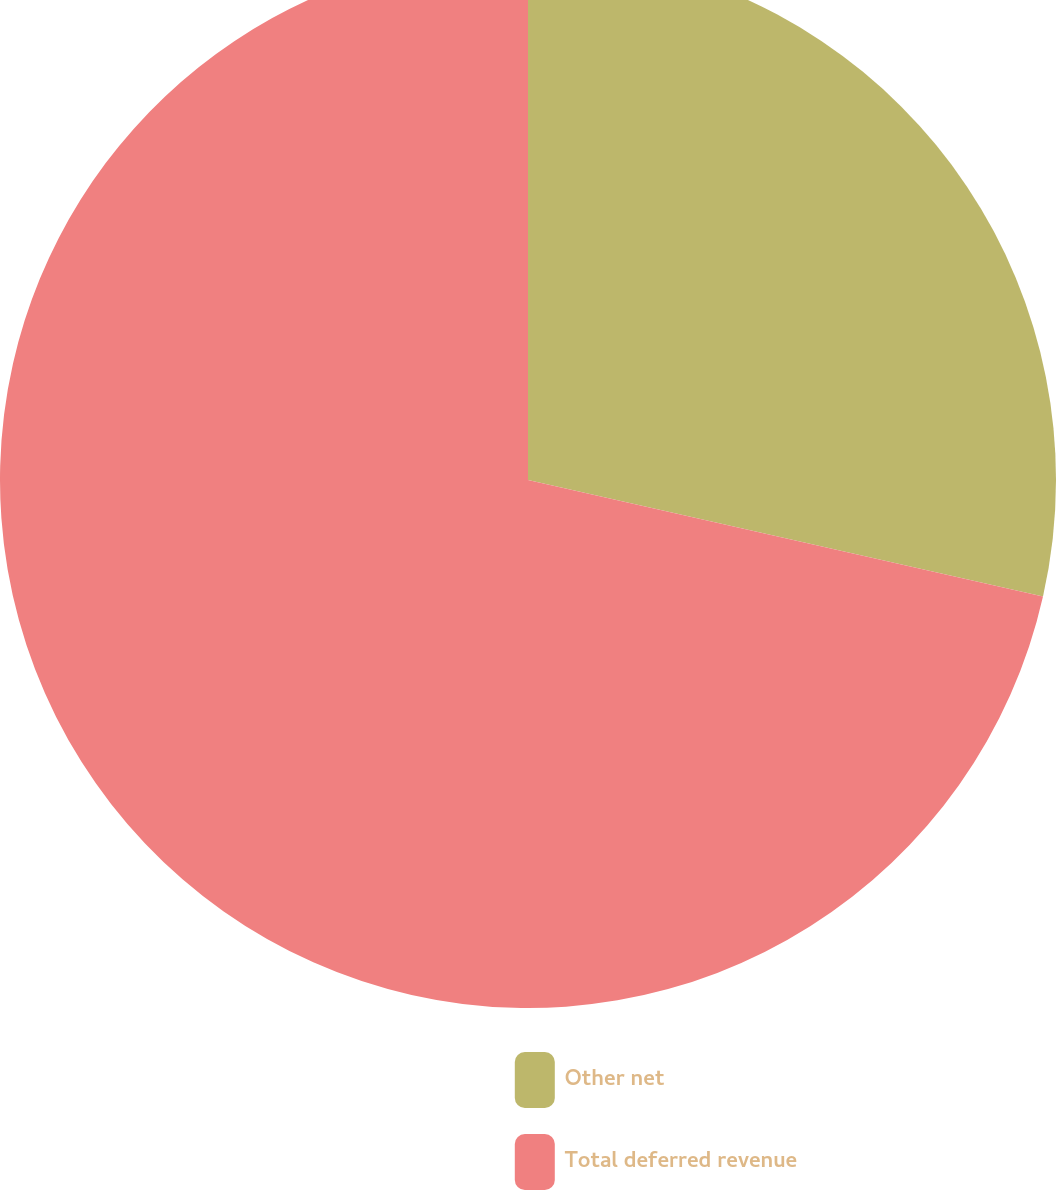Convert chart to OTSL. <chart><loc_0><loc_0><loc_500><loc_500><pie_chart><fcel>Other net<fcel>Total deferred revenue<nl><fcel>28.54%<fcel>71.46%<nl></chart> 